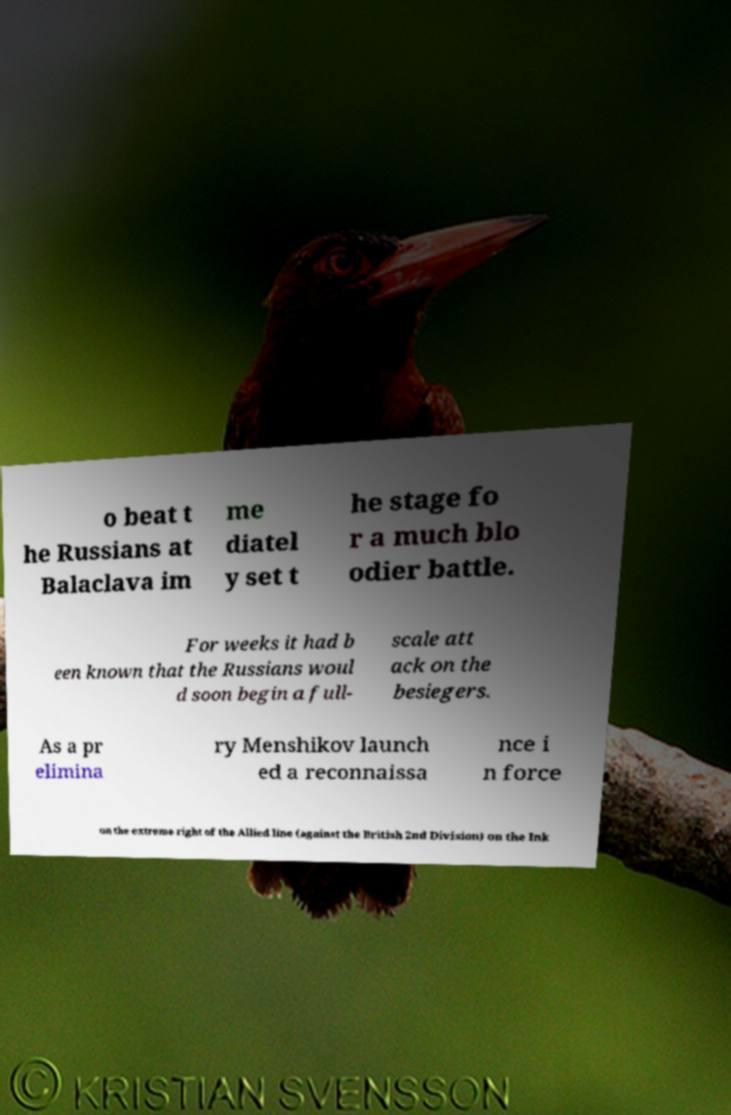Can you read and provide the text displayed in the image?This photo seems to have some interesting text. Can you extract and type it out for me? o beat t he Russians at Balaclava im me diatel y set t he stage fo r a much blo odier battle. For weeks it had b een known that the Russians woul d soon begin a full- scale att ack on the besiegers. As a pr elimina ry Menshikov launch ed a reconnaissa nce i n force on the extreme right of the Allied line (against the British 2nd Division) on the Ink 